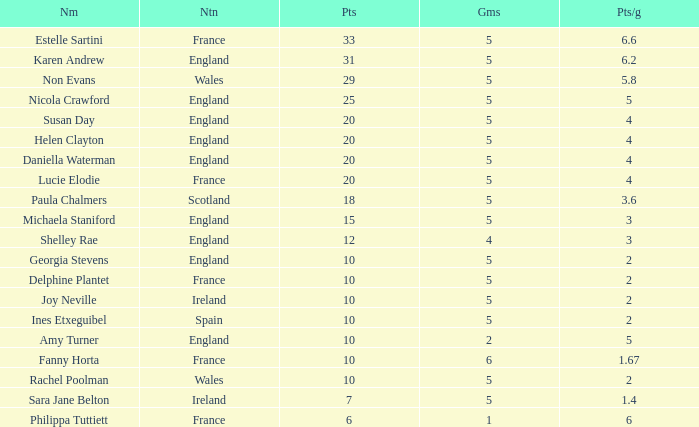Can you tell me the lowest Pts/game that has the Name of philippa tuttiett, and the Points larger then 6? None. Could you help me parse every detail presented in this table? {'header': ['Nm', 'Ntn', 'Pts', 'Gms', 'Pts/g'], 'rows': [['Estelle Sartini', 'France', '33', '5', '6.6'], ['Karen Andrew', 'England', '31', '5', '6.2'], ['Non Evans', 'Wales', '29', '5', '5.8'], ['Nicola Crawford', 'England', '25', '5', '5'], ['Susan Day', 'England', '20', '5', '4'], ['Helen Clayton', 'England', '20', '5', '4'], ['Daniella Waterman', 'England', '20', '5', '4'], ['Lucie Elodie', 'France', '20', '5', '4'], ['Paula Chalmers', 'Scotland', '18', '5', '3.6'], ['Michaela Staniford', 'England', '15', '5', '3'], ['Shelley Rae', 'England', '12', '4', '3'], ['Georgia Stevens', 'England', '10', '5', '2'], ['Delphine Plantet', 'France', '10', '5', '2'], ['Joy Neville', 'Ireland', '10', '5', '2'], ['Ines Etxeguibel', 'Spain', '10', '5', '2'], ['Amy Turner', 'England', '10', '2', '5'], ['Fanny Horta', 'France', '10', '6', '1.67'], ['Rachel Poolman', 'Wales', '10', '5', '2'], ['Sara Jane Belton', 'Ireland', '7', '5', '1.4'], ['Philippa Tuttiett', 'France', '6', '1', '6']]} 